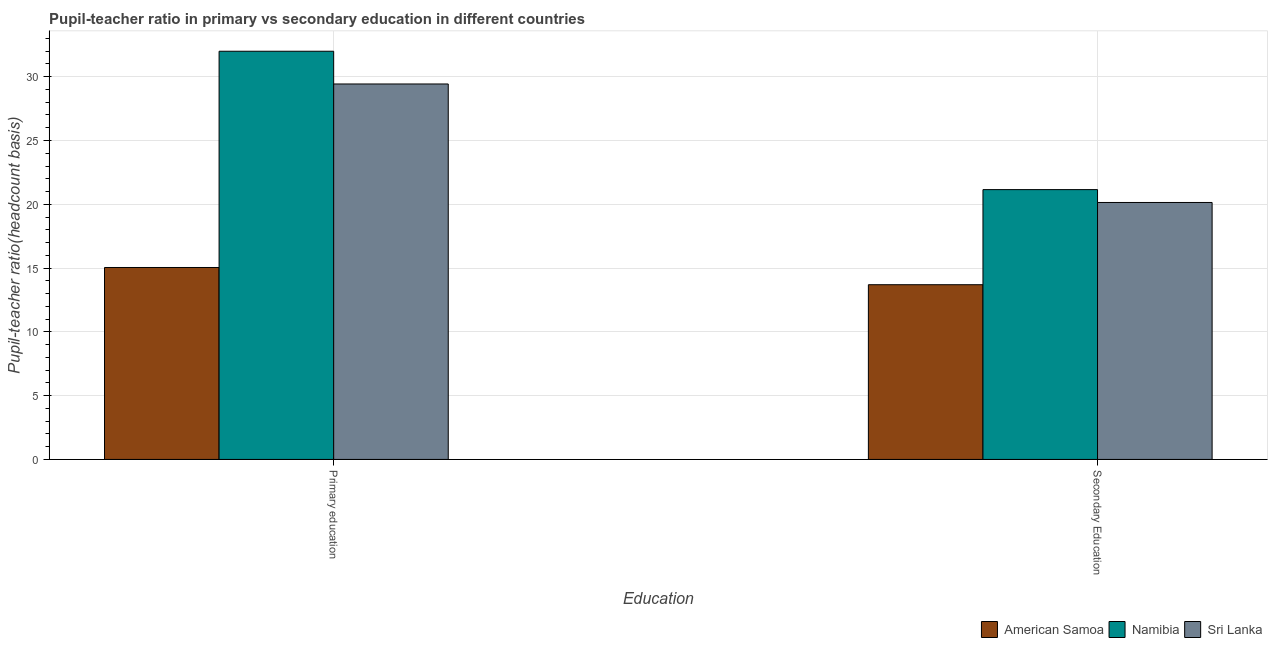How many groups of bars are there?
Keep it short and to the point. 2. How many bars are there on the 1st tick from the left?
Your answer should be compact. 3. How many bars are there on the 1st tick from the right?
Your answer should be compact. 3. What is the pupil-teacher ratio in primary education in American Samoa?
Your answer should be very brief. 15.05. Across all countries, what is the maximum pupil teacher ratio on secondary education?
Offer a terse response. 21.15. Across all countries, what is the minimum pupil teacher ratio on secondary education?
Give a very brief answer. 13.7. In which country was the pupil teacher ratio on secondary education maximum?
Your answer should be compact. Namibia. In which country was the pupil teacher ratio on secondary education minimum?
Your answer should be very brief. American Samoa. What is the total pupil-teacher ratio in primary education in the graph?
Keep it short and to the point. 76.48. What is the difference between the pupil-teacher ratio in primary education in Sri Lanka and that in Namibia?
Offer a very short reply. -2.57. What is the difference between the pupil-teacher ratio in primary education in American Samoa and the pupil teacher ratio on secondary education in Namibia?
Provide a succinct answer. -6.1. What is the average pupil teacher ratio on secondary education per country?
Your answer should be very brief. 18.33. What is the difference between the pupil teacher ratio on secondary education and pupil-teacher ratio in primary education in Sri Lanka?
Your answer should be very brief. -9.29. What is the ratio of the pupil teacher ratio on secondary education in Namibia to that in Sri Lanka?
Offer a very short reply. 1.05. Is the pupil-teacher ratio in primary education in Sri Lanka less than that in American Samoa?
Give a very brief answer. No. What does the 3rd bar from the left in Secondary Education represents?
Offer a terse response. Sri Lanka. What does the 2nd bar from the right in Primary education represents?
Ensure brevity in your answer.  Namibia. How many bars are there?
Give a very brief answer. 6. How many countries are there in the graph?
Offer a terse response. 3. What is the difference between two consecutive major ticks on the Y-axis?
Keep it short and to the point. 5. Are the values on the major ticks of Y-axis written in scientific E-notation?
Provide a succinct answer. No. What is the title of the graph?
Your answer should be very brief. Pupil-teacher ratio in primary vs secondary education in different countries. What is the label or title of the X-axis?
Provide a succinct answer. Education. What is the label or title of the Y-axis?
Offer a terse response. Pupil-teacher ratio(headcount basis). What is the Pupil-teacher ratio(headcount basis) of American Samoa in Primary education?
Offer a very short reply. 15.05. What is the Pupil-teacher ratio(headcount basis) of Namibia in Primary education?
Offer a very short reply. 32. What is the Pupil-teacher ratio(headcount basis) of Sri Lanka in Primary education?
Your answer should be compact. 29.43. What is the Pupil-teacher ratio(headcount basis) in American Samoa in Secondary Education?
Give a very brief answer. 13.7. What is the Pupil-teacher ratio(headcount basis) of Namibia in Secondary Education?
Keep it short and to the point. 21.15. What is the Pupil-teacher ratio(headcount basis) of Sri Lanka in Secondary Education?
Offer a terse response. 20.14. Across all Education, what is the maximum Pupil-teacher ratio(headcount basis) of American Samoa?
Your answer should be very brief. 15.05. Across all Education, what is the maximum Pupil-teacher ratio(headcount basis) of Namibia?
Make the answer very short. 32. Across all Education, what is the maximum Pupil-teacher ratio(headcount basis) in Sri Lanka?
Your answer should be very brief. 29.43. Across all Education, what is the minimum Pupil-teacher ratio(headcount basis) of American Samoa?
Provide a short and direct response. 13.7. Across all Education, what is the minimum Pupil-teacher ratio(headcount basis) in Namibia?
Offer a very short reply. 21.15. Across all Education, what is the minimum Pupil-teacher ratio(headcount basis) in Sri Lanka?
Provide a succinct answer. 20.14. What is the total Pupil-teacher ratio(headcount basis) of American Samoa in the graph?
Give a very brief answer. 28.74. What is the total Pupil-teacher ratio(headcount basis) of Namibia in the graph?
Make the answer very short. 53.15. What is the total Pupil-teacher ratio(headcount basis) in Sri Lanka in the graph?
Offer a terse response. 49.57. What is the difference between the Pupil-teacher ratio(headcount basis) of American Samoa in Primary education and that in Secondary Education?
Keep it short and to the point. 1.35. What is the difference between the Pupil-teacher ratio(headcount basis) in Namibia in Primary education and that in Secondary Education?
Your answer should be very brief. 10.85. What is the difference between the Pupil-teacher ratio(headcount basis) in Sri Lanka in Primary education and that in Secondary Education?
Offer a very short reply. 9.29. What is the difference between the Pupil-teacher ratio(headcount basis) in American Samoa in Primary education and the Pupil-teacher ratio(headcount basis) in Namibia in Secondary Education?
Keep it short and to the point. -6.1. What is the difference between the Pupil-teacher ratio(headcount basis) of American Samoa in Primary education and the Pupil-teacher ratio(headcount basis) of Sri Lanka in Secondary Education?
Provide a short and direct response. -5.1. What is the difference between the Pupil-teacher ratio(headcount basis) of Namibia in Primary education and the Pupil-teacher ratio(headcount basis) of Sri Lanka in Secondary Education?
Ensure brevity in your answer.  11.86. What is the average Pupil-teacher ratio(headcount basis) of American Samoa per Education?
Give a very brief answer. 14.37. What is the average Pupil-teacher ratio(headcount basis) in Namibia per Education?
Make the answer very short. 26.57. What is the average Pupil-teacher ratio(headcount basis) in Sri Lanka per Education?
Your answer should be compact. 24.79. What is the difference between the Pupil-teacher ratio(headcount basis) in American Samoa and Pupil-teacher ratio(headcount basis) in Namibia in Primary education?
Keep it short and to the point. -16.95. What is the difference between the Pupil-teacher ratio(headcount basis) in American Samoa and Pupil-teacher ratio(headcount basis) in Sri Lanka in Primary education?
Keep it short and to the point. -14.39. What is the difference between the Pupil-teacher ratio(headcount basis) in Namibia and Pupil-teacher ratio(headcount basis) in Sri Lanka in Primary education?
Provide a short and direct response. 2.57. What is the difference between the Pupil-teacher ratio(headcount basis) in American Samoa and Pupil-teacher ratio(headcount basis) in Namibia in Secondary Education?
Your answer should be compact. -7.46. What is the difference between the Pupil-teacher ratio(headcount basis) of American Samoa and Pupil-teacher ratio(headcount basis) of Sri Lanka in Secondary Education?
Your response must be concise. -6.45. What is the difference between the Pupil-teacher ratio(headcount basis) of Namibia and Pupil-teacher ratio(headcount basis) of Sri Lanka in Secondary Education?
Ensure brevity in your answer.  1.01. What is the ratio of the Pupil-teacher ratio(headcount basis) of American Samoa in Primary education to that in Secondary Education?
Provide a short and direct response. 1.1. What is the ratio of the Pupil-teacher ratio(headcount basis) of Namibia in Primary education to that in Secondary Education?
Provide a succinct answer. 1.51. What is the ratio of the Pupil-teacher ratio(headcount basis) of Sri Lanka in Primary education to that in Secondary Education?
Your answer should be compact. 1.46. What is the difference between the highest and the second highest Pupil-teacher ratio(headcount basis) in American Samoa?
Your answer should be very brief. 1.35. What is the difference between the highest and the second highest Pupil-teacher ratio(headcount basis) of Namibia?
Give a very brief answer. 10.85. What is the difference between the highest and the second highest Pupil-teacher ratio(headcount basis) of Sri Lanka?
Offer a very short reply. 9.29. What is the difference between the highest and the lowest Pupil-teacher ratio(headcount basis) in American Samoa?
Provide a succinct answer. 1.35. What is the difference between the highest and the lowest Pupil-teacher ratio(headcount basis) of Namibia?
Make the answer very short. 10.85. What is the difference between the highest and the lowest Pupil-teacher ratio(headcount basis) of Sri Lanka?
Offer a terse response. 9.29. 